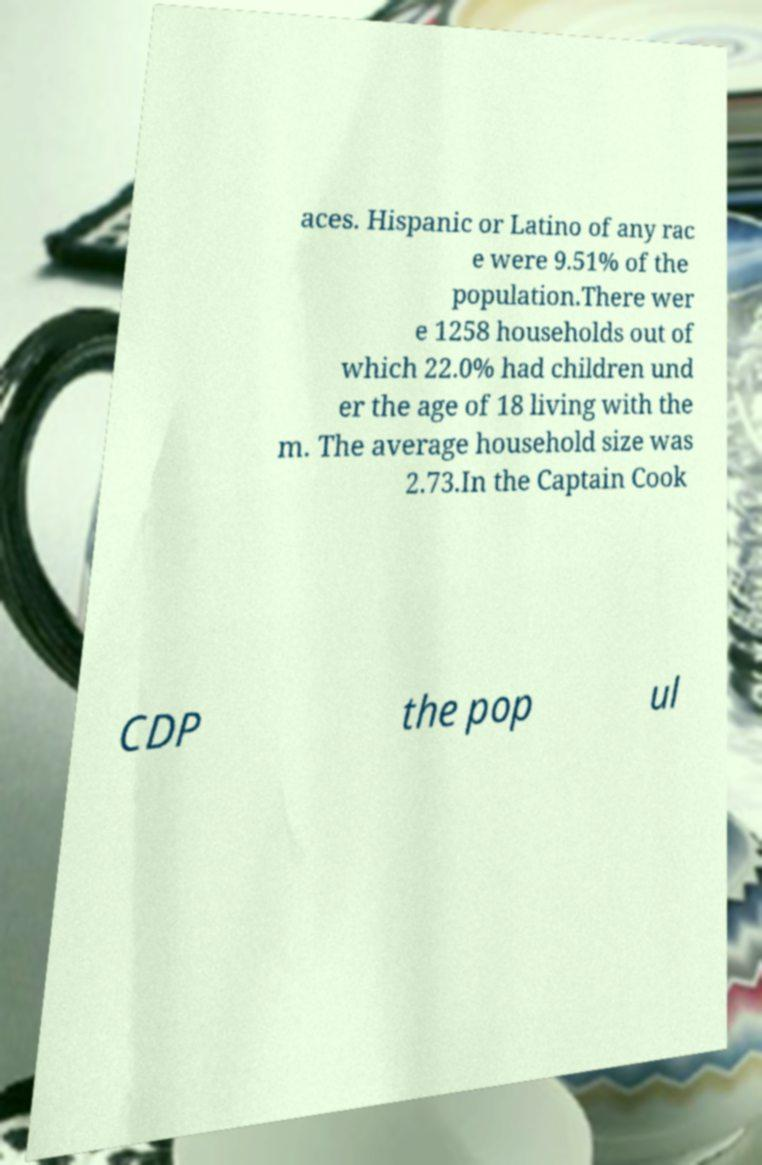There's text embedded in this image that I need extracted. Can you transcribe it verbatim? aces. Hispanic or Latino of any rac e were 9.51% of the population.There wer e 1258 households out of which 22.0% had children und er the age of 18 living with the m. The average household size was 2.73.In the Captain Cook CDP the pop ul 